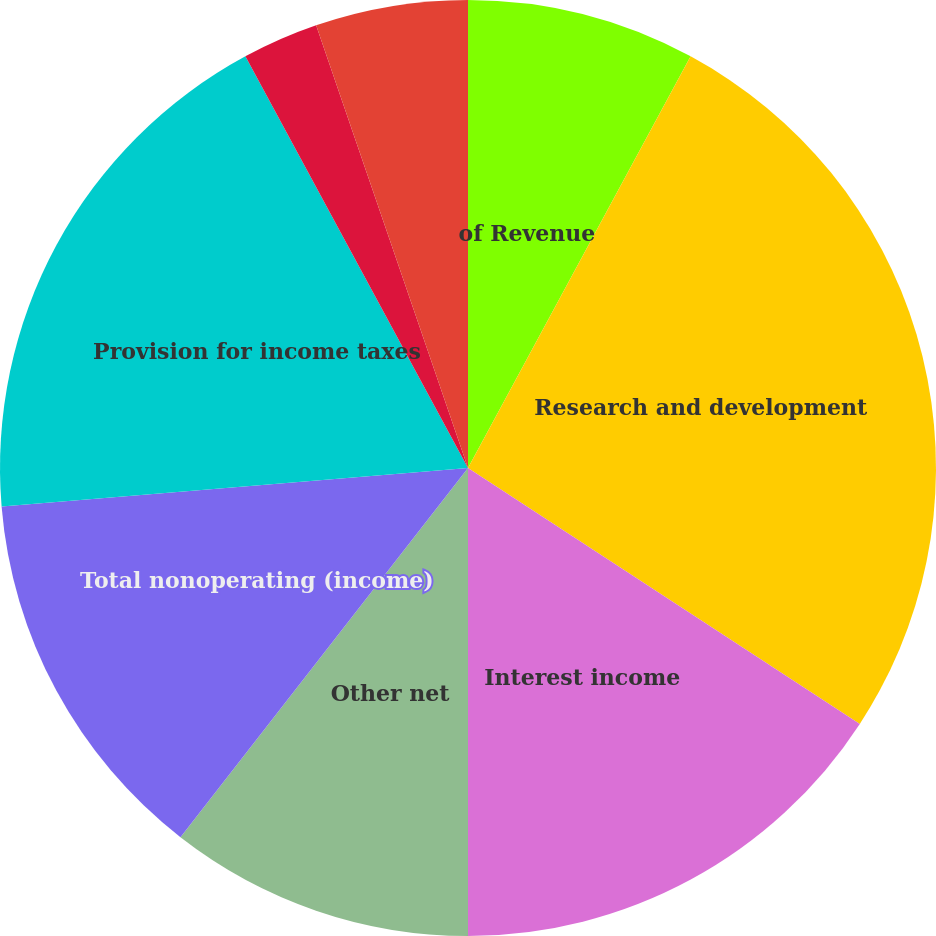Convert chart to OTSL. <chart><loc_0><loc_0><loc_500><loc_500><pie_chart><fcel>of Revenue<fcel>Research and development<fcel>Interest income<fcel>Other net<fcel>Total nonoperating (income)<fcel>Provision for income taxes<fcel>Income from continuing<fcel>Net income<fcel>Dividends declared per share<nl><fcel>7.89%<fcel>26.32%<fcel>15.79%<fcel>10.53%<fcel>13.16%<fcel>18.42%<fcel>2.63%<fcel>5.26%<fcel>0.0%<nl></chart> 